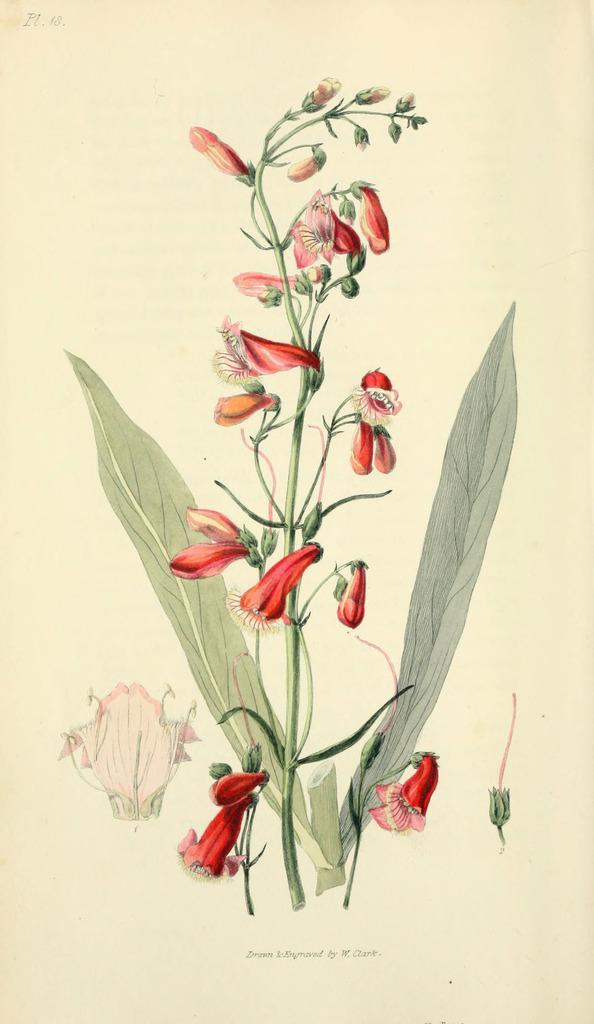Could you give a brief overview of what you see in this image? In this image I can see the plant and few flowers in red color and I can see the cream color background. 